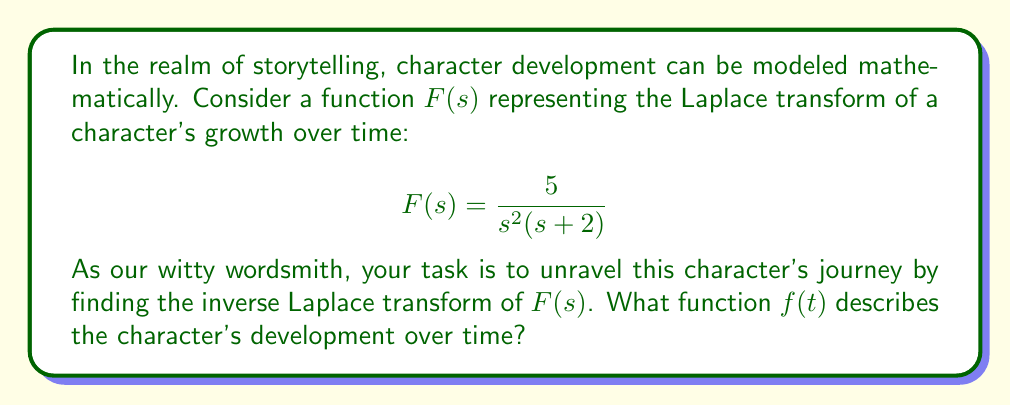Provide a solution to this math problem. To find the inverse Laplace transform, we'll follow these steps:

1) First, let's decompose $F(s)$ into partial fractions:

   $$\frac{5}{s^2(s+2)} = \frac{A}{s} + \frac{B}{s^2} + \frac{C}{s+2}$$

2) Multiply both sides by $s^2(s+2)$:

   $$5 = A(s+2) + Bs + C(s^2)$$

3) Equate coefficients:
   $s^2: C = 0$
   $s^1: A + B = 0$
   $s^0: 2A = 5$

4) Solve the system:
   $A = \frac{5}{2}$, $B = -\frac{5}{2}$, $C = 0$

5) Rewrite $F(s)$ as:

   $$F(s) = \frac{5/2}{s} - \frac{5/2}{s^2}$$

6) Now, we can use Laplace transform tables to find the inverse:

   $\mathcal{L}^{-1}\{\frac{1}{s}\} = 1$
   $\mathcal{L}^{-1}\{\frac{1}{s^2}\} = t$

7) Therefore, the inverse Laplace transform is:

   $$f(t) = \frac{5}{2} - \frac{5}{2}t$$

This function represents the character's development over time, starting strong but gradually declining, perhaps indicating a tragic hero's arc.
Answer: $f(t) = \frac{5}{2}(1-t)$ 